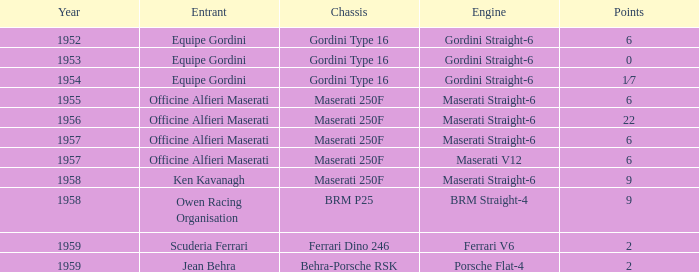What is the entry of a maserati 250f chassis with 6 points and predating 1957? Officine Alfieri Maserati. 